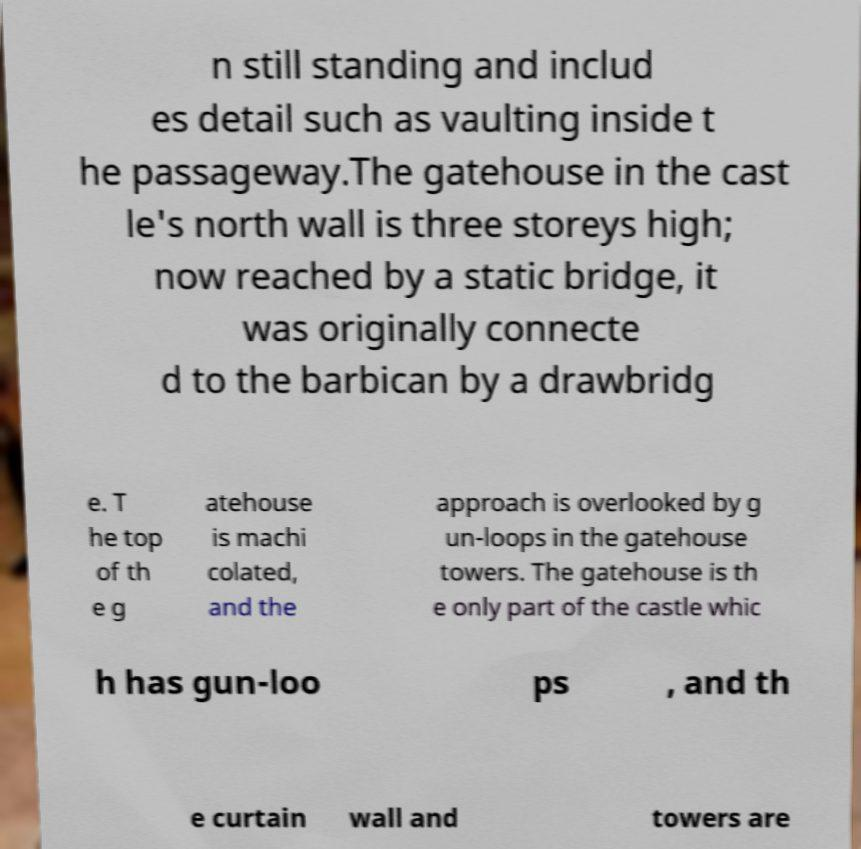Could you extract and type out the text from this image? n still standing and includ es detail such as vaulting inside t he passageway.The gatehouse in the cast le's north wall is three storeys high; now reached by a static bridge, it was originally connecte d to the barbican by a drawbridg e. T he top of th e g atehouse is machi colated, and the approach is overlooked by g un-loops in the gatehouse towers. The gatehouse is th e only part of the castle whic h has gun-loo ps , and th e curtain wall and towers are 